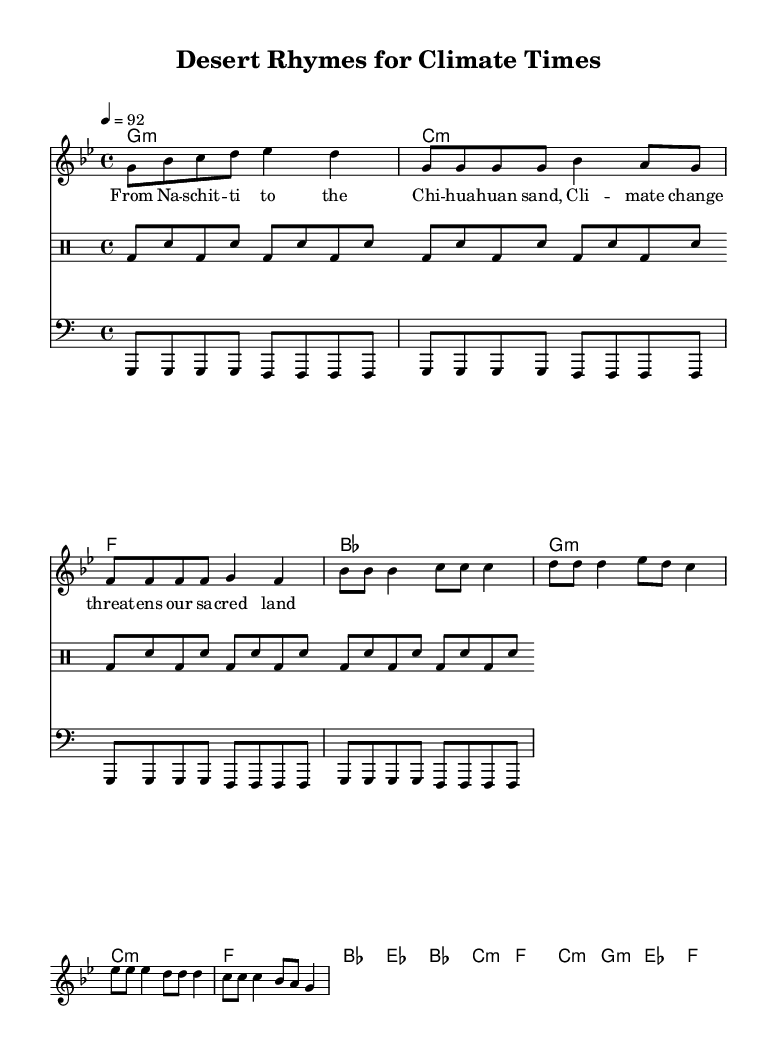What is the key signature of this music? The key signature is G minor, which has two flats (B flat and E flat). This is determined by the "g" in the key signature line at the beginning of the score.
Answer: G minor What is the time signature of this piece? The time signature is 4/4, indicated by the notation at the beginning of the score, showing that there are four beats in each measure, with a quarter note getting one beat.
Answer: 4/4 What is the tempo marking for this rap? The tempo marking states "4 = 92," which indicates that there are 92 beats per minute. This is found in the tempo line right after the time signature.
Answer: 92 How many measures are there in the melody section? Counting the measures in the melody part provides a total of 8 measures from the "Intro" to the "Bridge" sections, as indicated by the bars in the score.
Answer: 8 What chord is used in the chorus? The chorus section features the chords E flat, B flat, C minor, and F, as notated in the chord names. Specifically, the first chord is E flat, which is identifiable in the respective chorus measures.
Answer: E flat Which part repeats throughout the drumline? The drumline consists of a repeated pattern of kick drum (bd) and snare (sn), repeating every four measures, as shown in the drummode section.
Answer: bd & sn What is the main theme of the lyrics in this rap? The lyrics focus on climate change's impact on sacred land, as evidenced by the thematic content in the lines that mention "climate change" and "sacred land" which appear within the lyrical structure.
Answer: Climate change 